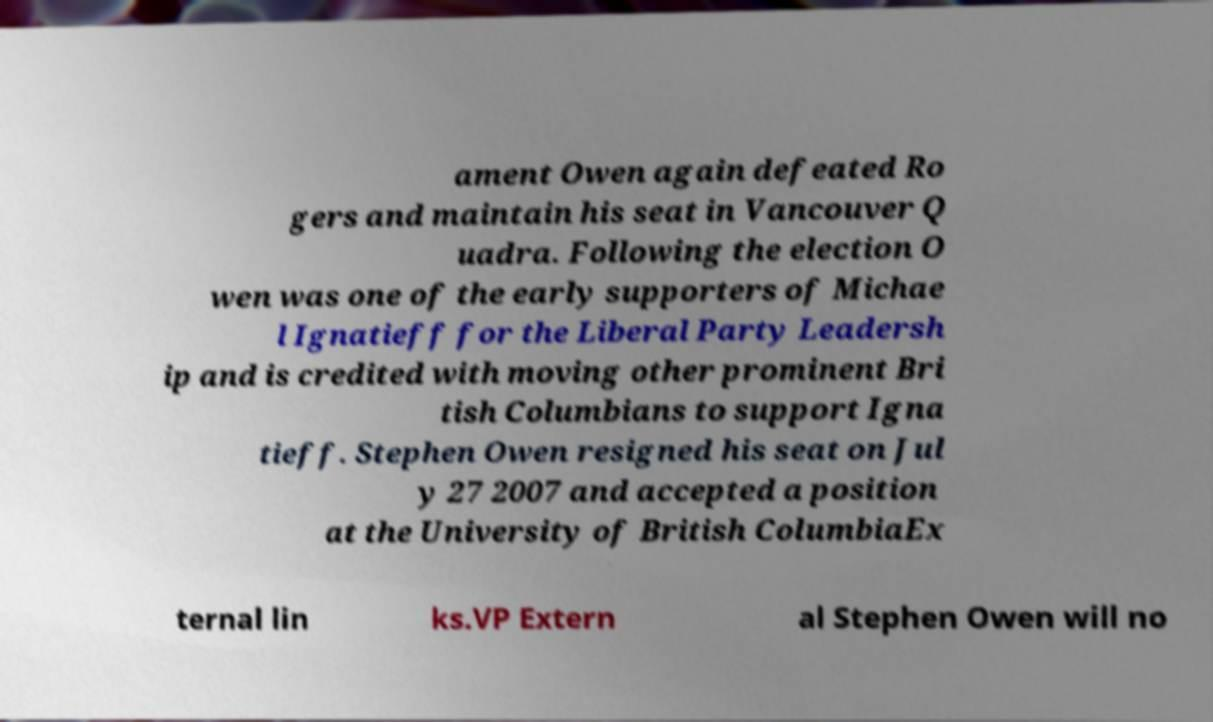Could you assist in decoding the text presented in this image and type it out clearly? ament Owen again defeated Ro gers and maintain his seat in Vancouver Q uadra. Following the election O wen was one of the early supporters of Michae l Ignatieff for the Liberal Party Leadersh ip and is credited with moving other prominent Bri tish Columbians to support Igna tieff. Stephen Owen resigned his seat on Jul y 27 2007 and accepted a position at the University of British ColumbiaEx ternal lin ks.VP Extern al Stephen Owen will no 